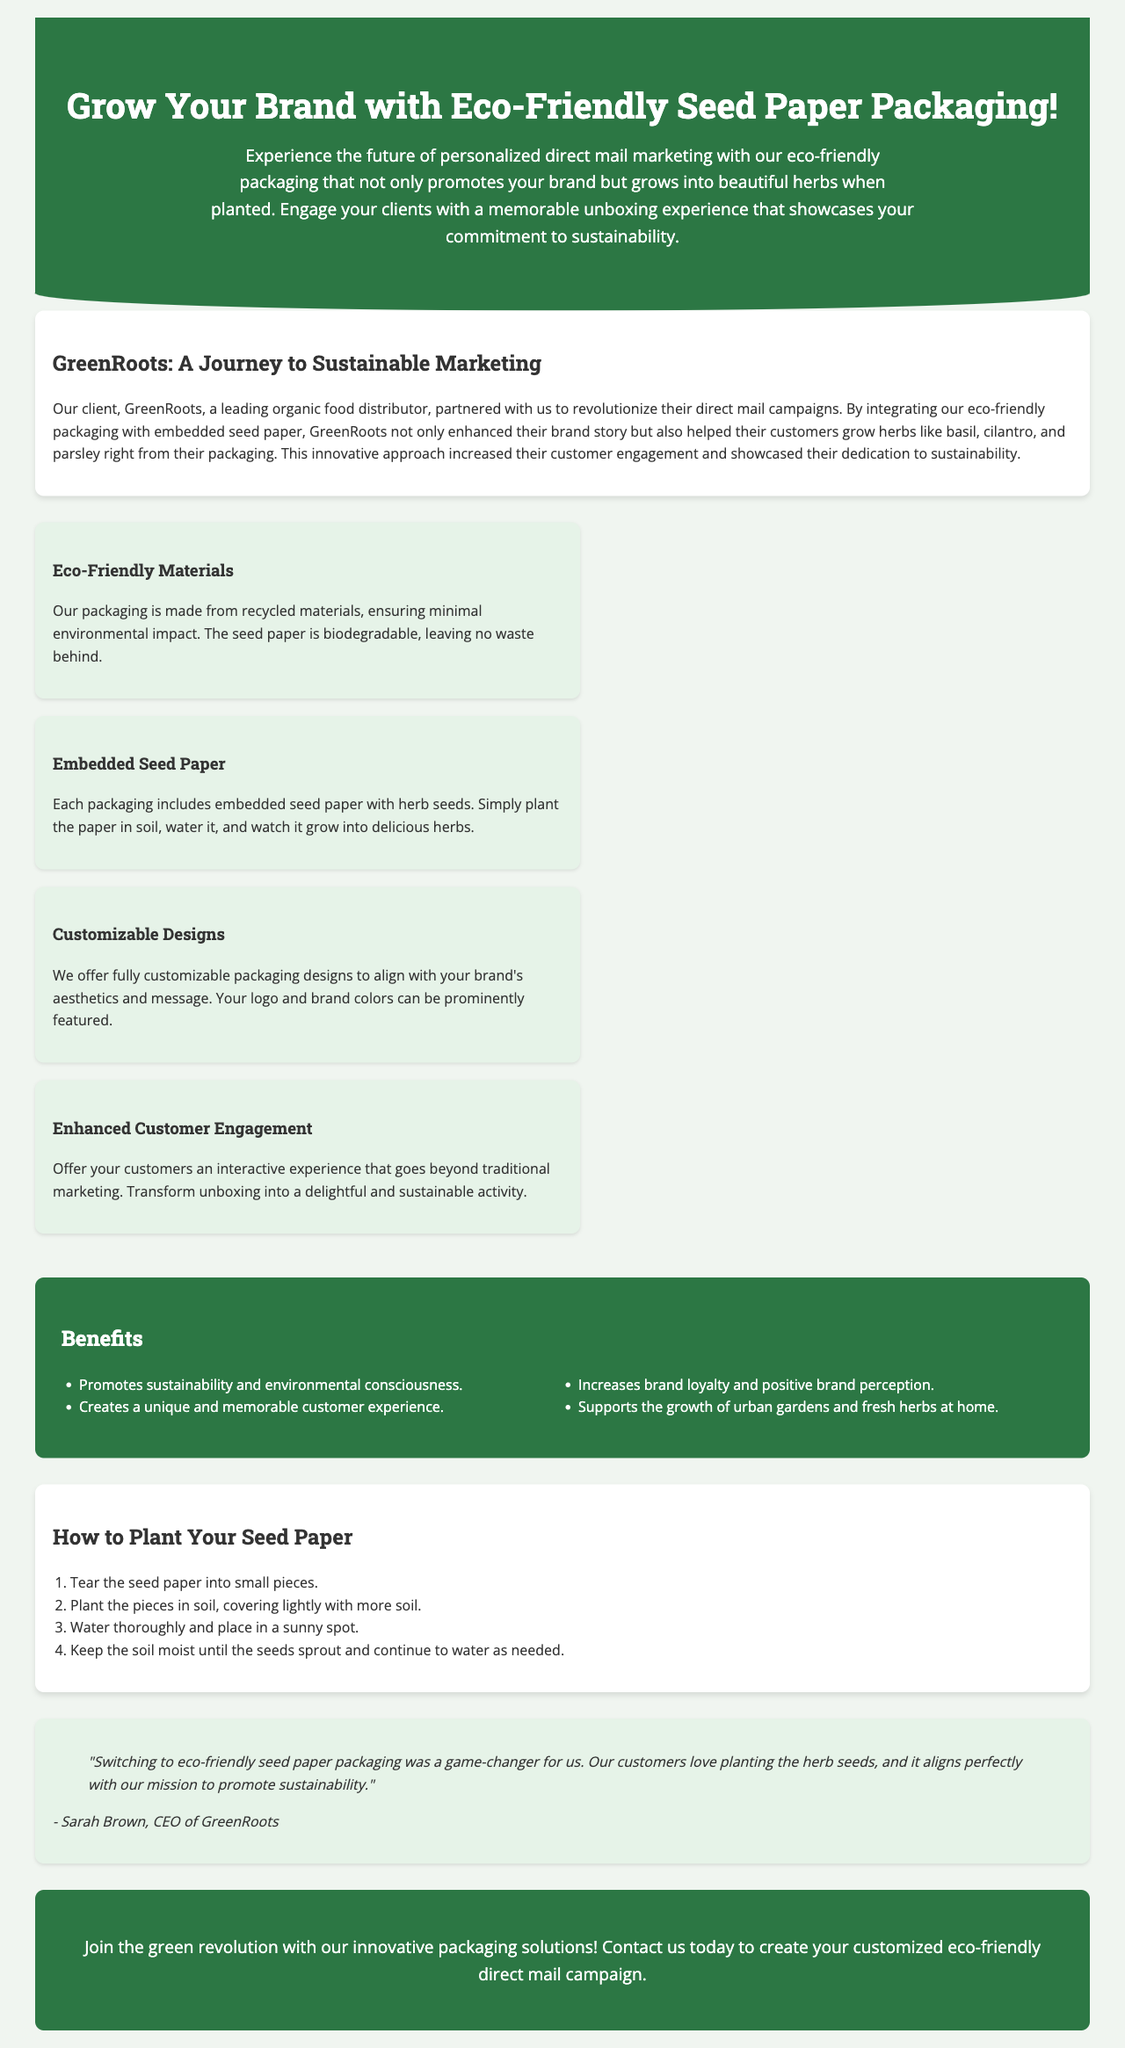What is the name of the client featured in the document? The client featured in the document is GreenRoots, which is highlighted for its partnership related to sustainable marketing.
Answer: GreenRoots What types of herbs can be grown from the packaging? The document mentions specific herbs that can be grown from the embedded seed paper, which are basil, cilantro, and parsley.
Answer: Basil, cilantro, parsley What is the main benefit of using eco-friendly seed paper packaging? The main benefit discussed in the document includes promoting sustainability and creating a unique customer experience.
Answer: Promotes sustainability How many steps are there in the "How to Plant Your Seed Paper" section? The document outlines a specific procedure in this section, which includes a list of steps; counting these steps determines the total.
Answer: 4 What color is the header background in the document? The document describes the header's background color, which is a specific distinct color used throughout the design.
Answer: Dark green What type of experience does the eco-friendly seed paper packaging aim to create? The document explains that the packaging provides an interactive, delightful, and sustainable unboxing experience for customers.
Answer: Interactive experience Who is quoted in the testimonial section? The document attributes a statement about the benefits of the eco-friendly packaging to a specific individual associated with the featured client.
Answer: Sarah Brown What is the call to action at the end of the document? The closing part of the document includes a prompt urging potential clients to engage and take action regarding the eco-friendly packaging solutions.
Answer: Contact us today 